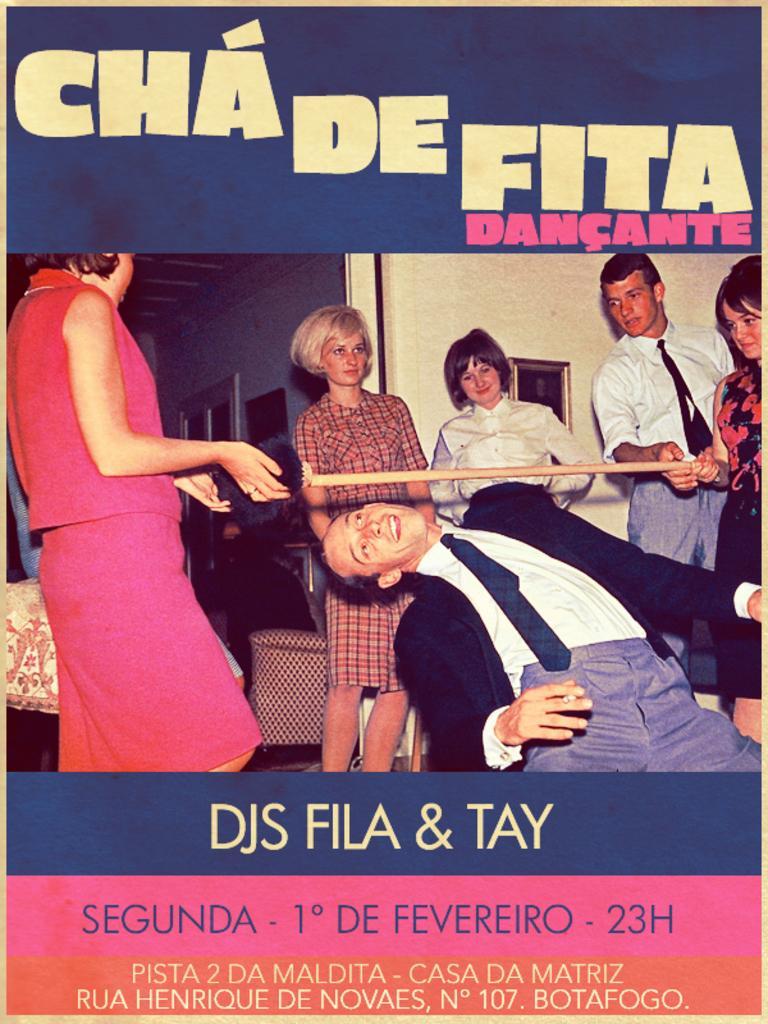Can you describe this image briefly? In this picture we can see a poster of people, chairs and there are photo frames attached to the wall. There are three persons holding a stick. At the top and bottom of the poster, it is written something. 